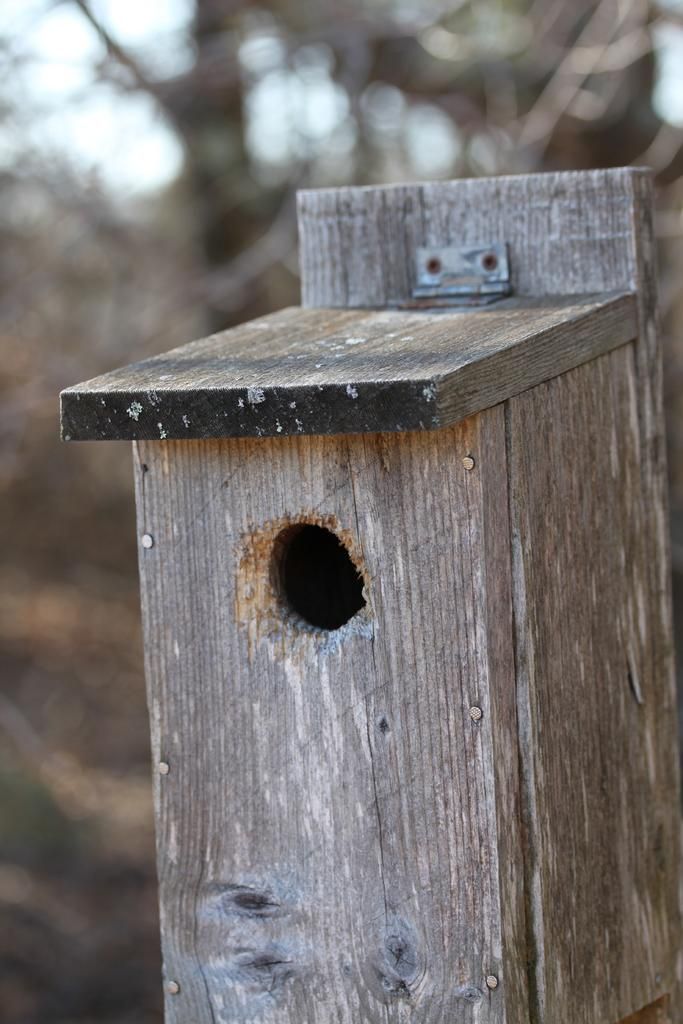What type of object is in the image? There is a wood box in the image. What feature does the wood box have? The wood box has a hole. What other feature can be seen on the wood box? The wood box has a hinge. Where is the nearest park to the wood box in the image? There is no information about a park or its location in the image. 